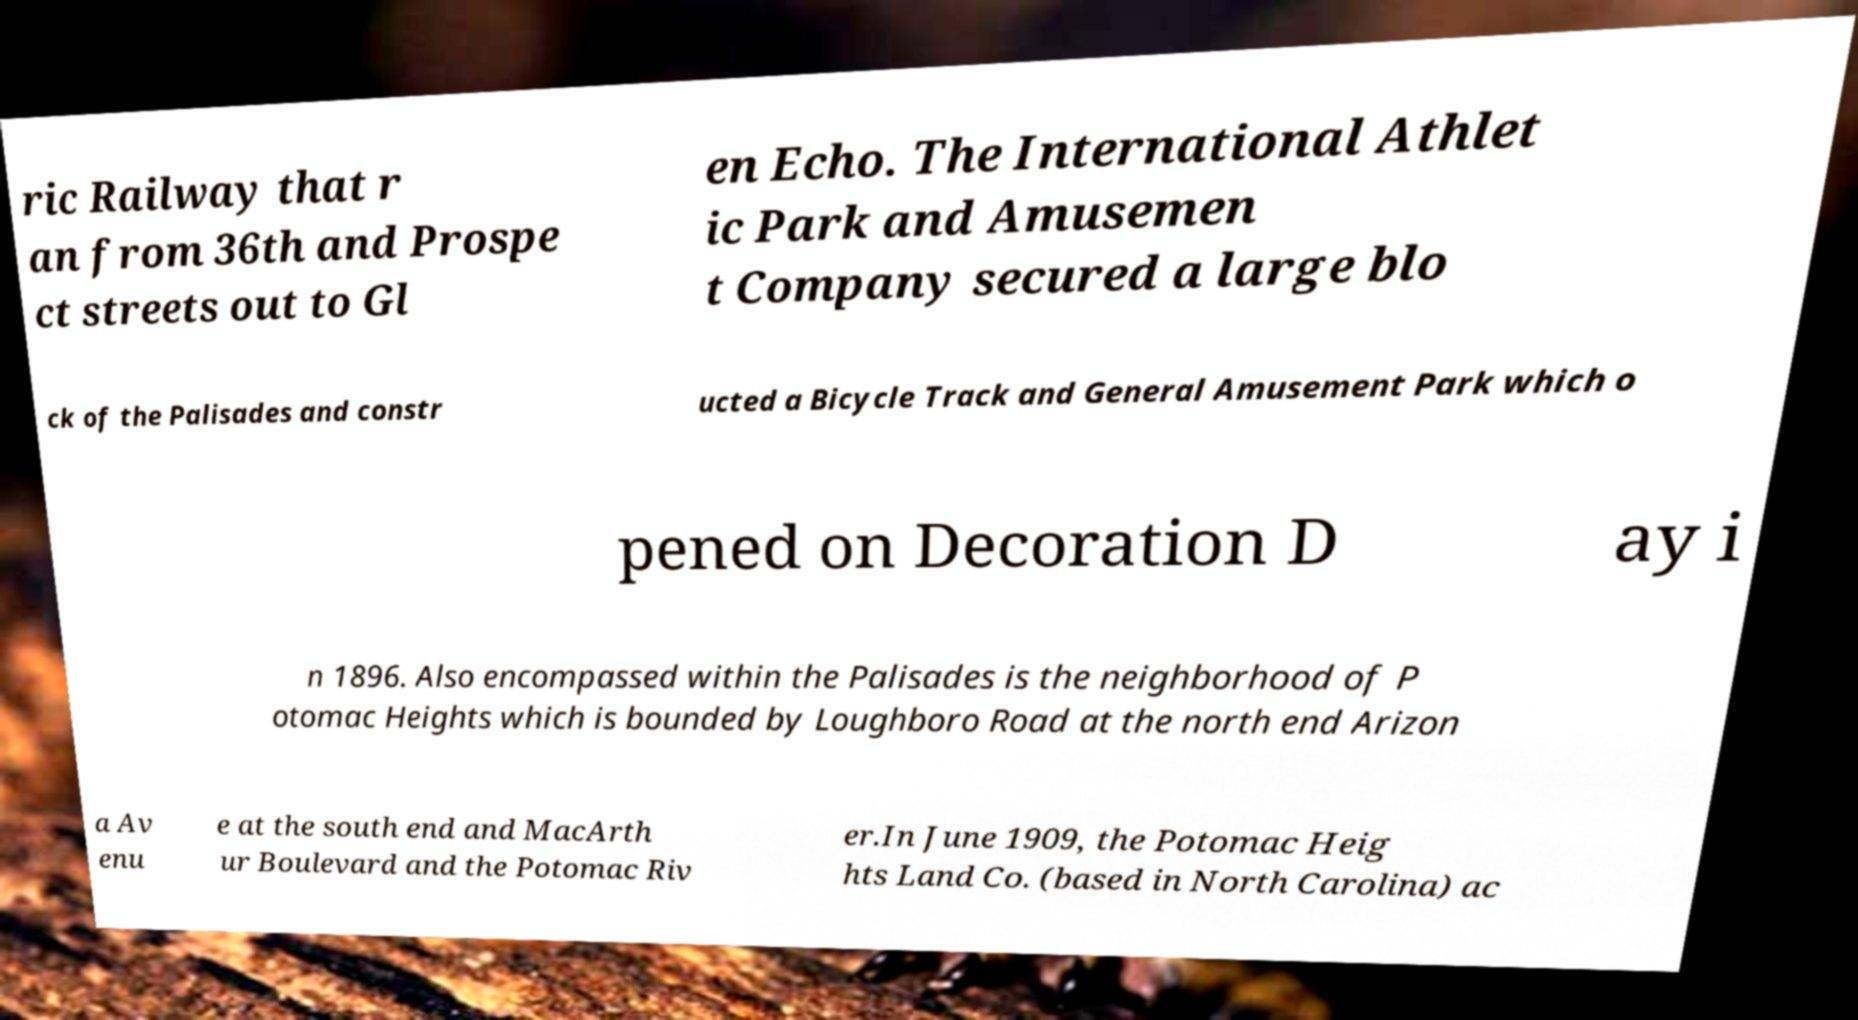Can you accurately transcribe the text from the provided image for me? ric Railway that r an from 36th and Prospe ct streets out to Gl en Echo. The International Athlet ic Park and Amusemen t Company secured a large blo ck of the Palisades and constr ucted a Bicycle Track and General Amusement Park which o pened on Decoration D ay i n 1896. Also encompassed within the Palisades is the neighborhood of P otomac Heights which is bounded by Loughboro Road at the north end Arizon a Av enu e at the south end and MacArth ur Boulevard and the Potomac Riv er.In June 1909, the Potomac Heig hts Land Co. (based in North Carolina) ac 